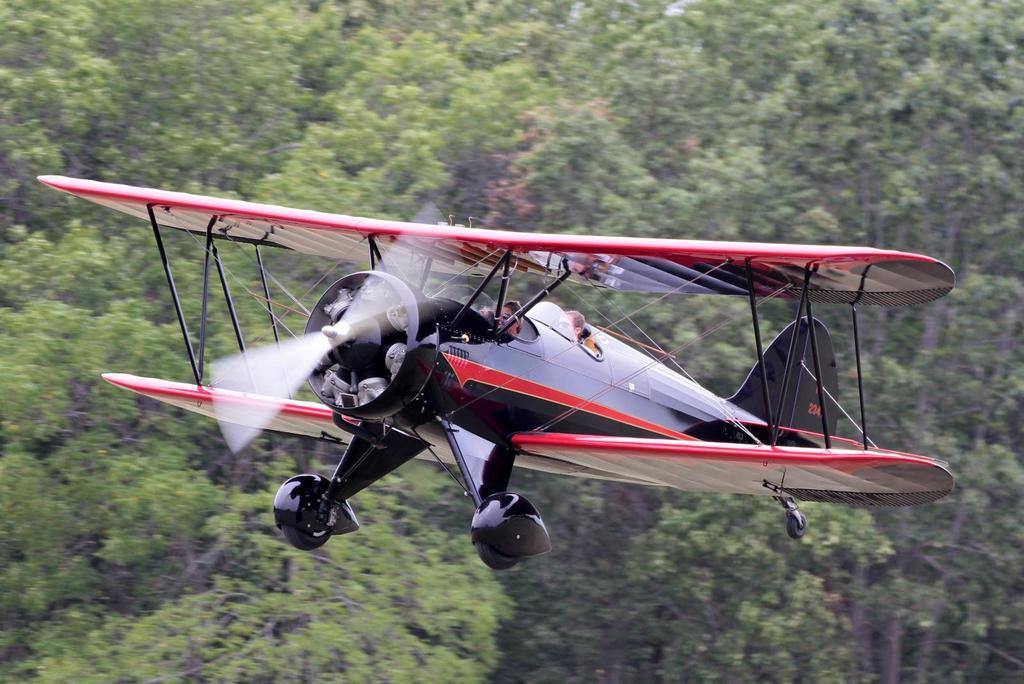What is the main subject of the image? The main subject of the image is an air craft. What is the air craft doing in the image? The air craft is flying in the air. What are the key features of the air craft? The air craft has a propeller and wings. What can be seen in the background of the image? There are trees visible in the image. What type of trains can be seen passing through the place in the image? There are no trains or places mentioned in the image; it features an air craft flying with trees in the background. 